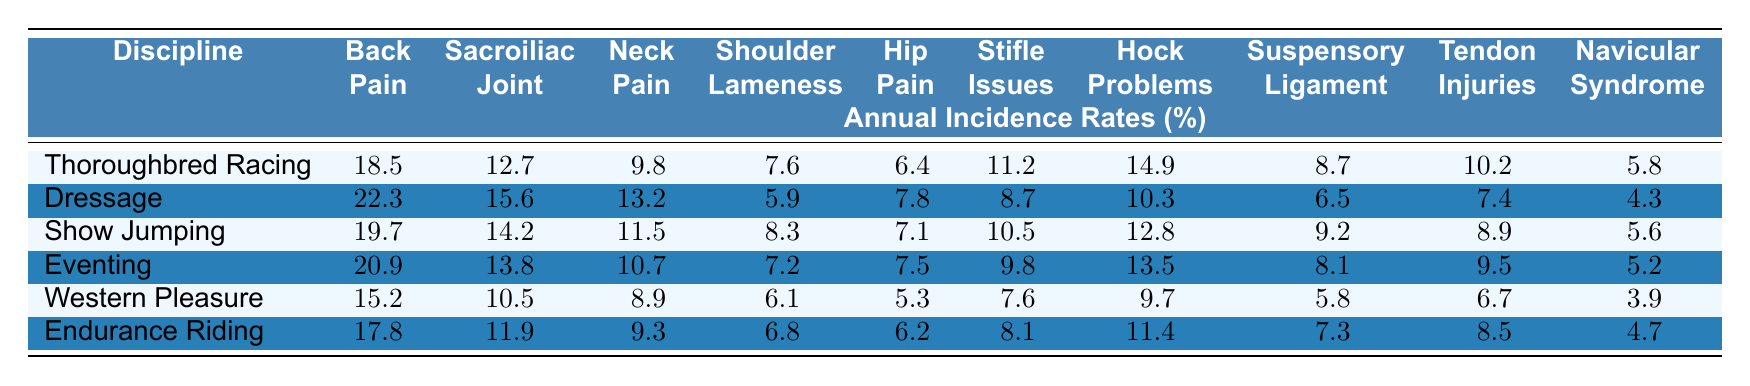What is the annual incidence rate of back pain in dressage? According to the table, the value for back pain in dressage is directly listed under the corresponding column. The value is 22.3%.
Answer: 22.3% Which discipline has the highest incidence rate of shoulder lameness? By examining the shoulder lameness row, the highest value can be identified. The value for show jumping is 8.3%, which is higher than the others listed.
Answer: Show Jumping What is the average incidence of hip pain across all disciplines? To find the average, add all the incidence rates of hip pain (6.4 + 7.8 + 7.1 + 7.5 + 5.3 + 6.2 = 40.3) and divide by the number of disciplines (40.3 / 6 = 6.7167). Rounding gives approximately 6.7%.
Answer: 6.7% Is there a higher incidence of sacroiliac joint dysfunction in eventing than in western pleasure? The incidence rate for eventing is 13.8% and for western pleasure, it is 10.5%. Since 13.8% is greater than 10.5%, the statement is true.
Answer: Yes What are the two disciplines with the lowest incidence rates of navicular syndrome? The table shows that western pleasure has a navicular syndrome rate of 3.9% and dressage has a rate of 4.3%. Since 3.9% is lower than 4.3%, western pleasure has the lowest followed by dressage.
Answer: Western Pleasure and Dressage Which musculoskeletal issue consistently has the lowest incidence across all disciplines? By reviewing each row, navicular syndrome has the lowest values consistently, with the highest at 5.8% in thoroughbred racing.
Answer: Navicular Syndrome Calculate the difference in incidence rates of stifle issues between thoroughbred racing and endurance riding. The table states that stifle issues in thoroughbred racing is 11.2% while in endurance riding, it is 8.1%. The difference is calculated as 11.2 - 8.1 = 3.1%.
Answer: 3.1% What percentage of show jumping horses experience neck pain compared to those in dressage? The incidence of neck pain in show jumping is 11.5% and in dressage is 13.2%. The comparison shows that neck pain is higher in dressage compared to show jumping.
Answer: Higher in Dressage Identify the discipline with the lowest percentage of tendon injuries. Looking at the tendon injury column, the lowest percentage is found in western pleasure with a rate of 6.7%.
Answer: Western Pleasure Determine if endurance riding has a higher incidence rate of back pain than thoroughbred racing. Endurance riding's back pain rate is 17.8% while thoroughbred racing's is 18.5%. Since 17.8% is less than 18.5%, the statement is false.
Answer: No 